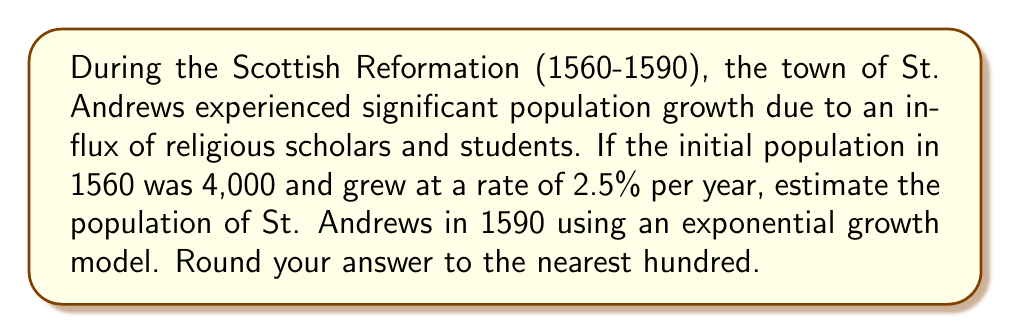Help me with this question. To solve this problem, we'll use the exponential growth formula:

$$A = P(1 + r)^t$$

Where:
$A$ = final amount (population in 1590)
$P$ = initial amount (population in 1560)
$r$ = growth rate (as a decimal)
$t$ = time period (in years)

Given:
$P = 4,000$
$r = 2.5\% = 0.025$
$t = 1590 - 1560 = 30$ years

Step 1: Substitute the values into the formula:
$$A = 4,000(1 + 0.025)^{30}$$

Step 2: Calculate the value inside the parentheses:
$$A = 4,000(1.025)^{30}$$

Step 3: Use a calculator to evaluate the expression:
$$A = 4,000 \times 2.0976 = 8,390.4$$

Step 4: Round to the nearest hundred:
$$A \approx 8,400$$

Therefore, the estimated population of St. Andrews in 1590 would be approximately 8,400 people.
Answer: 8,400 